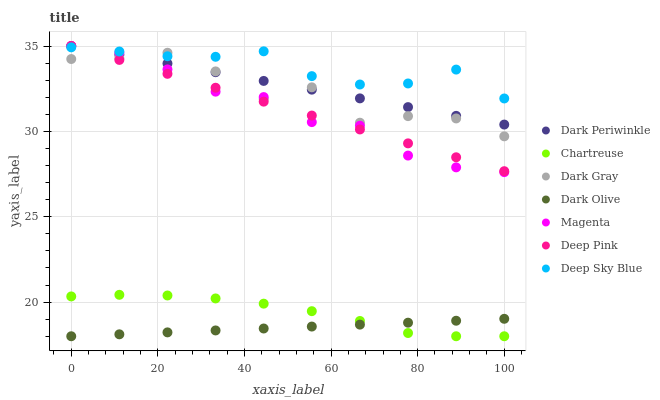Does Dark Olive have the minimum area under the curve?
Answer yes or no. Yes. Does Deep Sky Blue have the maximum area under the curve?
Answer yes or no. Yes. Does Dark Gray have the minimum area under the curve?
Answer yes or no. No. Does Dark Gray have the maximum area under the curve?
Answer yes or no. No. Is Deep Pink the smoothest?
Answer yes or no. Yes. Is Dark Gray the roughest?
Answer yes or no. Yes. Is Dark Olive the smoothest?
Answer yes or no. No. Is Dark Olive the roughest?
Answer yes or no. No. Does Dark Olive have the lowest value?
Answer yes or no. Yes. Does Dark Gray have the lowest value?
Answer yes or no. No. Does Dark Periwinkle have the highest value?
Answer yes or no. Yes. Does Dark Gray have the highest value?
Answer yes or no. No. Is Chartreuse less than Magenta?
Answer yes or no. Yes. Is Deep Sky Blue greater than Chartreuse?
Answer yes or no. Yes. Does Deep Pink intersect Deep Sky Blue?
Answer yes or no. Yes. Is Deep Pink less than Deep Sky Blue?
Answer yes or no. No. Is Deep Pink greater than Deep Sky Blue?
Answer yes or no. No. Does Chartreuse intersect Magenta?
Answer yes or no. No. 